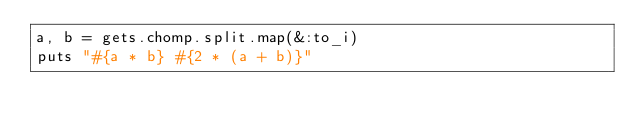Convert code to text. <code><loc_0><loc_0><loc_500><loc_500><_Ruby_>a, b = gets.chomp.split.map(&:to_i)
puts "#{a * b} #{2 * (a + b)}"</code> 